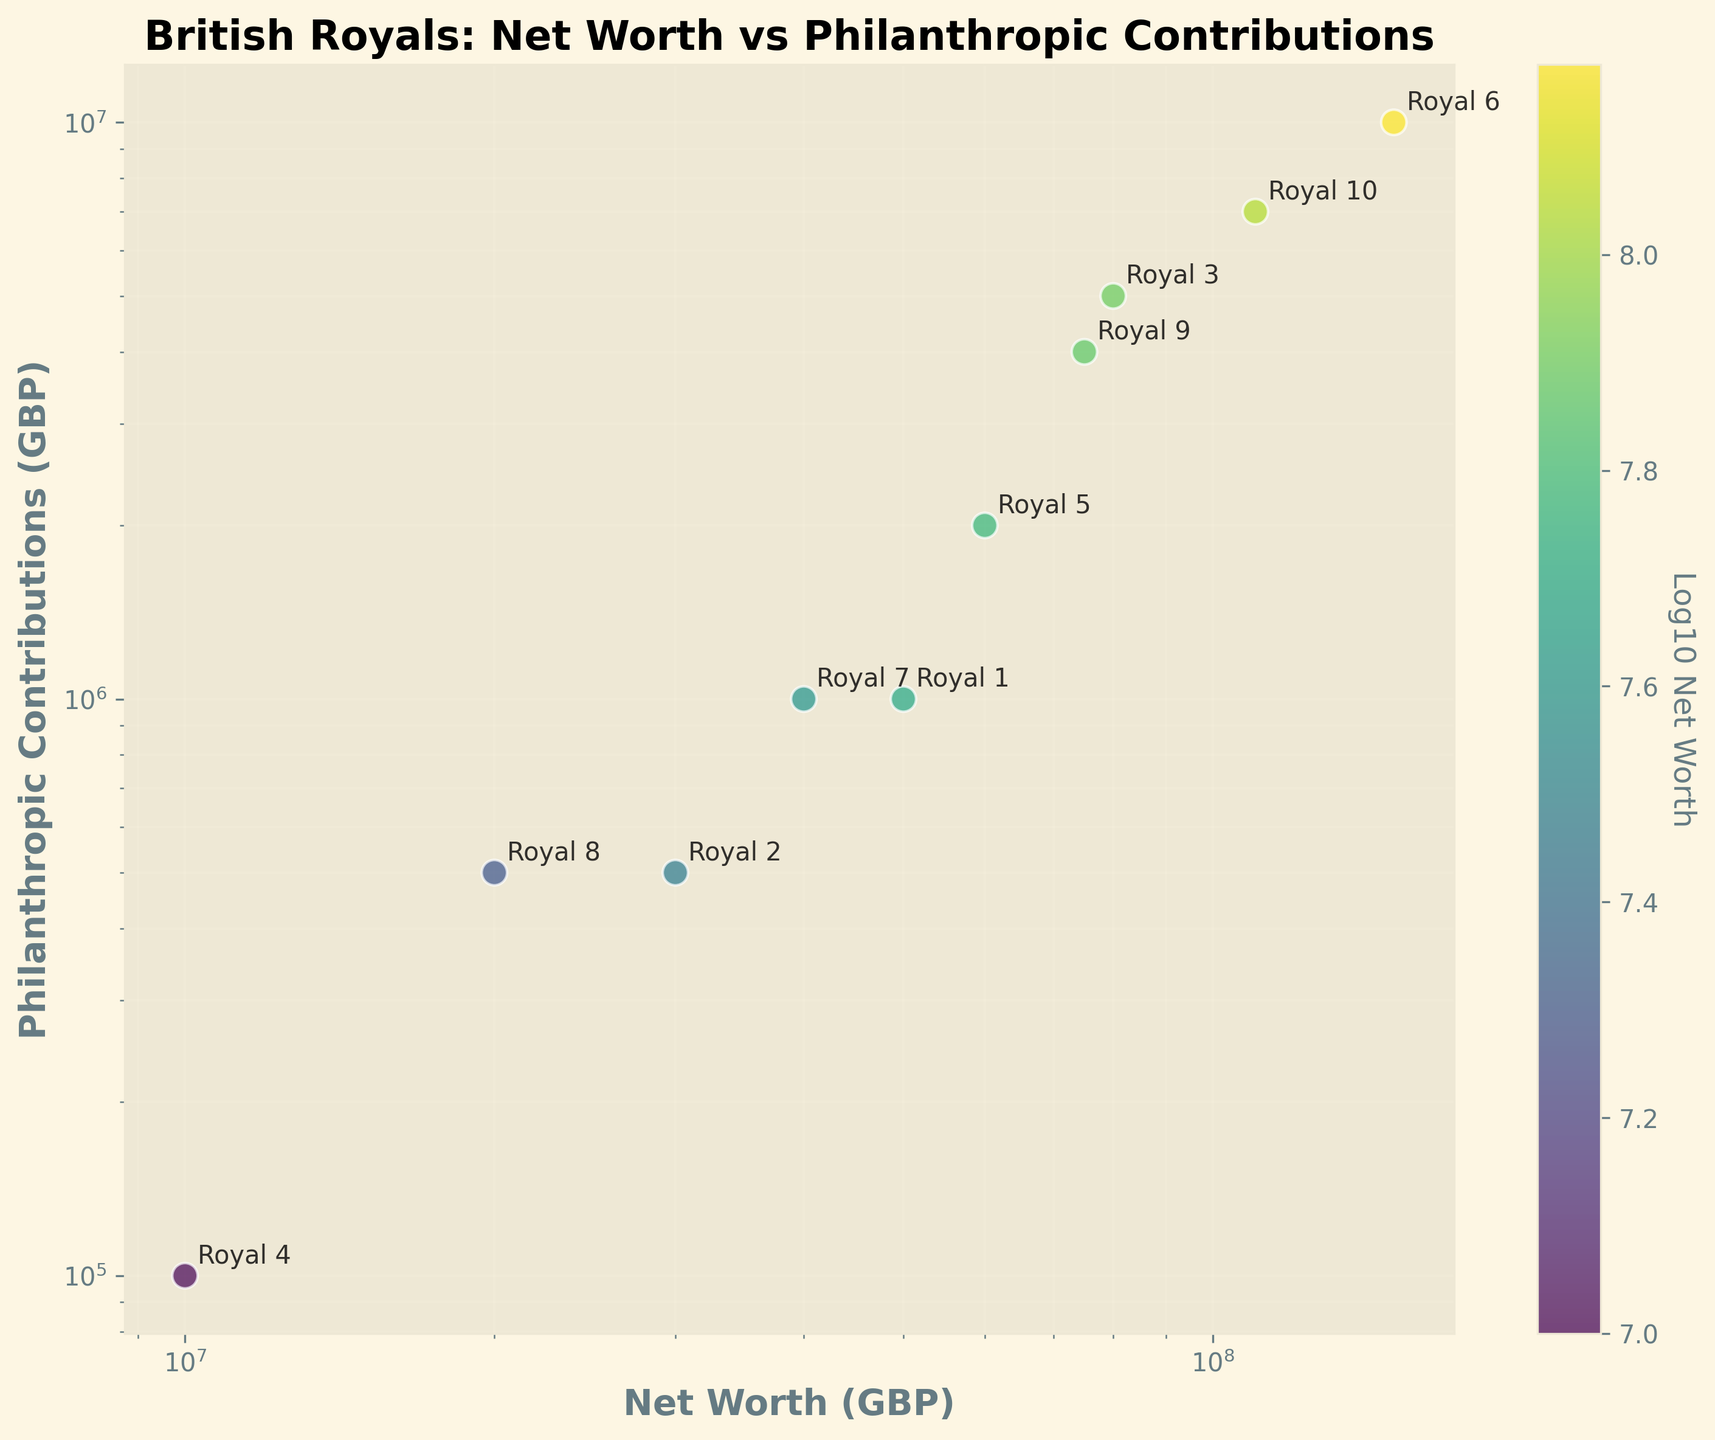What is the title of the scatter plot? The title of the scatter plot is displayed prominently at the top of the figure. It reads, "British Royals: Net Worth vs Philanthropic Contributions".
Answer: British Royals: Net Worth vs Philanthropic Contributions How many data points are there in the scatter plot? By counting the individual points marked on the scatter plot, we can see there are 10 data points, each representing a British royal.
Answer: 10 What is the net worth of the royal labeled 'Royal 6'? Looking at the annotations and the position of 'Royal 6' on the plot, we see that its x-coordinate (Net Worth) corresponds to £150,000,000.
Answer: £150,000,000 Which royal has the highest philanthropic contribution? By identifying the royal with the highest point on the y-axis (Philanthropic Contributions), we see that 'Royal 6' has the highest contribution of £10,000,000.
Answer: Royal 6 What is the x-axis label? The label of the x-axis is found below the axis. It is written as "Net Worth (GBP)".
Answer: Net Worth (GBP) What is the color gradient representing in the scatter plot? The color gradient represents the Log10 of Net Worth, as indicated by the color bar on the right side of the scatter plot.
Answer: Log10 of Net Worth Which royal has the lowest net worth and what is their philanthropic contribution? The royal with the lowest point on the x-axis (Net Worth) is 'Royal 4', and its philanthropic contribution (y-axis) is £100,000.
Answer: Royal 4, £100,000 By how much does the philanthropic contribution of 'Royal 3' exceed that of 'Royal 4'? 'Royal 3' has a contribution of £5,000,000 and 'Royal 4' has a contribution of £100,000. Subtracting these gives £5,000,000 - £100,000 = £4,900,000.
Answer: £4,900,000 What is the relationship between 'Royal 5' and 'Royal 10' in terms of net worth and philanthropic contributions? 'Royal 5' has a net worth of £60,000,000 and contribution of £2,000,000, whilst 'Royal 10' has a net worth of £110,000,000 and contribution of £7,000,000. Royal 10 has a higher net worth and contributes more philanthropically.
Answer: Royal 10 has higher net worth and contributes more Is there a general trend visible between net worth and philanthropic contributions? By observing the scatter plot, it appears that royals with higher net worths tend to have higher philanthropic contributions, indicating a positive correlation between net worth and philanthropic contributions.
Answer: Positive correlation What does the log scale on the axes imply about the data representation? The log scale on both axes implies that the data spans several orders of magnitude, allowing for easier visualization and comparison of values that would vary widely if plotted on a linear scale.
Answer: Easier visualization of varying magnitudes 